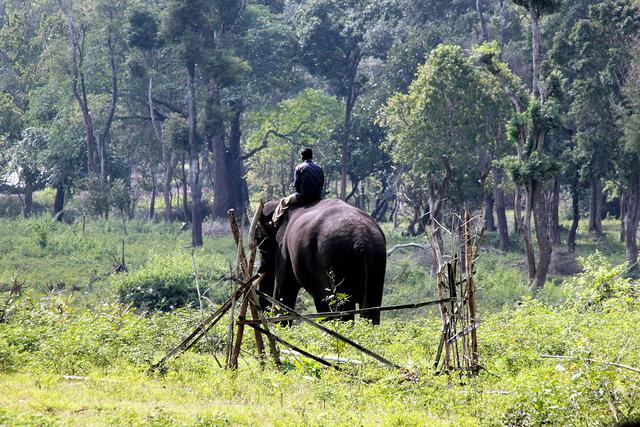How many people are riding?
Concise answer only. 1. Are there trees?
Keep it brief. Yes. Is this a herd?
Concise answer only. No. What color is the man wearing?
Quick response, please. Black. What is the person riding?
Keep it brief. Elephant. 